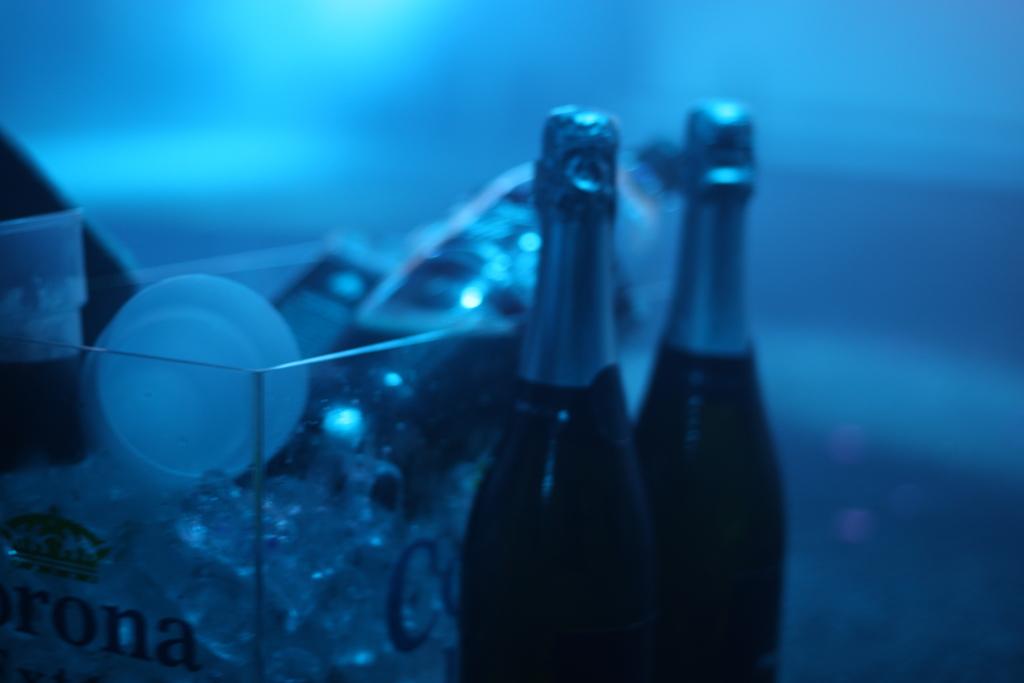What does the ice box say?
Make the answer very short. Corona. What brand is on the ice box?
Offer a very short reply. Corona. 